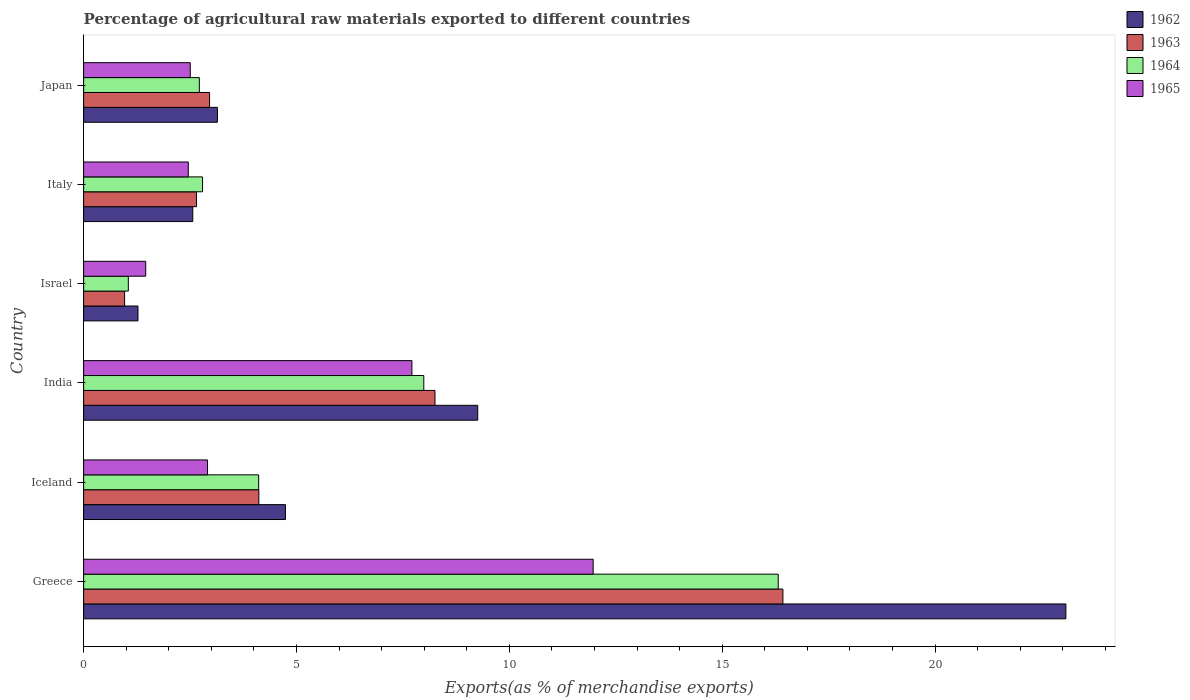How many different coloured bars are there?
Ensure brevity in your answer.  4. How many groups of bars are there?
Your answer should be compact. 6. Are the number of bars per tick equal to the number of legend labels?
Provide a short and direct response. Yes. How many bars are there on the 6th tick from the top?
Your answer should be compact. 4. In how many cases, is the number of bars for a given country not equal to the number of legend labels?
Keep it short and to the point. 0. What is the percentage of exports to different countries in 1962 in Israel?
Keep it short and to the point. 1.28. Across all countries, what is the maximum percentage of exports to different countries in 1963?
Your answer should be compact. 16.43. Across all countries, what is the minimum percentage of exports to different countries in 1963?
Offer a terse response. 0.96. In which country was the percentage of exports to different countries in 1963 maximum?
Provide a short and direct response. Greece. In which country was the percentage of exports to different countries in 1962 minimum?
Make the answer very short. Israel. What is the total percentage of exports to different countries in 1963 in the graph?
Your response must be concise. 35.37. What is the difference between the percentage of exports to different countries in 1963 in Greece and that in India?
Give a very brief answer. 8.17. What is the difference between the percentage of exports to different countries in 1965 in Italy and the percentage of exports to different countries in 1962 in Israel?
Offer a very short reply. 1.18. What is the average percentage of exports to different countries in 1962 per country?
Your answer should be very brief. 7.34. What is the difference between the percentage of exports to different countries in 1963 and percentage of exports to different countries in 1964 in Japan?
Your response must be concise. 0.24. In how many countries, is the percentage of exports to different countries in 1965 greater than 21 %?
Provide a succinct answer. 0. What is the ratio of the percentage of exports to different countries in 1964 in Greece to that in Iceland?
Provide a short and direct response. 3.97. What is the difference between the highest and the second highest percentage of exports to different countries in 1965?
Your answer should be compact. 4.26. What is the difference between the highest and the lowest percentage of exports to different countries in 1965?
Provide a succinct answer. 10.51. In how many countries, is the percentage of exports to different countries in 1964 greater than the average percentage of exports to different countries in 1964 taken over all countries?
Provide a succinct answer. 2. Is it the case that in every country, the sum of the percentage of exports to different countries in 1963 and percentage of exports to different countries in 1964 is greater than the sum of percentage of exports to different countries in 1962 and percentage of exports to different countries in 1965?
Offer a very short reply. No. What does the 2nd bar from the top in Japan represents?
Provide a succinct answer. 1964. What does the 3rd bar from the bottom in Italy represents?
Offer a terse response. 1964. How many bars are there?
Your answer should be compact. 24. What is the difference between two consecutive major ticks on the X-axis?
Keep it short and to the point. 5. Are the values on the major ticks of X-axis written in scientific E-notation?
Your response must be concise. No. How many legend labels are there?
Offer a terse response. 4. What is the title of the graph?
Keep it short and to the point. Percentage of agricultural raw materials exported to different countries. What is the label or title of the X-axis?
Offer a terse response. Exports(as % of merchandise exports). What is the Exports(as % of merchandise exports) of 1962 in Greece?
Ensure brevity in your answer.  23.07. What is the Exports(as % of merchandise exports) of 1963 in Greece?
Make the answer very short. 16.43. What is the Exports(as % of merchandise exports) of 1964 in Greece?
Offer a very short reply. 16.32. What is the Exports(as % of merchandise exports) in 1965 in Greece?
Provide a short and direct response. 11.97. What is the Exports(as % of merchandise exports) in 1962 in Iceland?
Your response must be concise. 4.74. What is the Exports(as % of merchandise exports) in 1963 in Iceland?
Your response must be concise. 4.12. What is the Exports(as % of merchandise exports) of 1964 in Iceland?
Provide a succinct answer. 4.11. What is the Exports(as % of merchandise exports) in 1965 in Iceland?
Provide a succinct answer. 2.91. What is the Exports(as % of merchandise exports) in 1962 in India?
Ensure brevity in your answer.  9.26. What is the Exports(as % of merchandise exports) in 1963 in India?
Make the answer very short. 8.25. What is the Exports(as % of merchandise exports) of 1964 in India?
Provide a short and direct response. 7.99. What is the Exports(as % of merchandise exports) of 1965 in India?
Offer a very short reply. 7.71. What is the Exports(as % of merchandise exports) in 1962 in Israel?
Offer a terse response. 1.28. What is the Exports(as % of merchandise exports) of 1963 in Israel?
Your response must be concise. 0.96. What is the Exports(as % of merchandise exports) in 1964 in Israel?
Give a very brief answer. 1.05. What is the Exports(as % of merchandise exports) in 1965 in Israel?
Ensure brevity in your answer.  1.46. What is the Exports(as % of merchandise exports) of 1962 in Italy?
Give a very brief answer. 2.56. What is the Exports(as % of merchandise exports) in 1963 in Italy?
Provide a short and direct response. 2.65. What is the Exports(as % of merchandise exports) in 1964 in Italy?
Keep it short and to the point. 2.79. What is the Exports(as % of merchandise exports) in 1965 in Italy?
Provide a succinct answer. 2.46. What is the Exports(as % of merchandise exports) in 1962 in Japan?
Provide a succinct answer. 3.14. What is the Exports(as % of merchandise exports) in 1963 in Japan?
Offer a terse response. 2.96. What is the Exports(as % of merchandise exports) of 1964 in Japan?
Provide a short and direct response. 2.72. What is the Exports(as % of merchandise exports) of 1965 in Japan?
Your answer should be compact. 2.5. Across all countries, what is the maximum Exports(as % of merchandise exports) in 1962?
Offer a terse response. 23.07. Across all countries, what is the maximum Exports(as % of merchandise exports) of 1963?
Make the answer very short. 16.43. Across all countries, what is the maximum Exports(as % of merchandise exports) in 1964?
Your answer should be compact. 16.32. Across all countries, what is the maximum Exports(as % of merchandise exports) of 1965?
Offer a terse response. 11.97. Across all countries, what is the minimum Exports(as % of merchandise exports) of 1962?
Ensure brevity in your answer.  1.28. Across all countries, what is the minimum Exports(as % of merchandise exports) of 1963?
Your response must be concise. 0.96. Across all countries, what is the minimum Exports(as % of merchandise exports) in 1964?
Give a very brief answer. 1.05. Across all countries, what is the minimum Exports(as % of merchandise exports) in 1965?
Your response must be concise. 1.46. What is the total Exports(as % of merchandise exports) of 1962 in the graph?
Keep it short and to the point. 44.05. What is the total Exports(as % of merchandise exports) in 1963 in the graph?
Make the answer very short. 35.37. What is the total Exports(as % of merchandise exports) in 1964 in the graph?
Make the answer very short. 34.98. What is the total Exports(as % of merchandise exports) in 1965 in the graph?
Your response must be concise. 29.01. What is the difference between the Exports(as % of merchandise exports) of 1962 in Greece and that in Iceland?
Ensure brevity in your answer.  18.33. What is the difference between the Exports(as % of merchandise exports) of 1963 in Greece and that in Iceland?
Keep it short and to the point. 12.31. What is the difference between the Exports(as % of merchandise exports) in 1964 in Greece and that in Iceland?
Provide a short and direct response. 12.2. What is the difference between the Exports(as % of merchandise exports) in 1965 in Greece and that in Iceland?
Make the answer very short. 9.06. What is the difference between the Exports(as % of merchandise exports) in 1962 in Greece and that in India?
Provide a short and direct response. 13.81. What is the difference between the Exports(as % of merchandise exports) of 1963 in Greece and that in India?
Make the answer very short. 8.17. What is the difference between the Exports(as % of merchandise exports) in 1964 in Greece and that in India?
Provide a succinct answer. 8.33. What is the difference between the Exports(as % of merchandise exports) in 1965 in Greece and that in India?
Provide a short and direct response. 4.26. What is the difference between the Exports(as % of merchandise exports) in 1962 in Greece and that in Israel?
Keep it short and to the point. 21.8. What is the difference between the Exports(as % of merchandise exports) in 1963 in Greece and that in Israel?
Keep it short and to the point. 15.46. What is the difference between the Exports(as % of merchandise exports) in 1964 in Greece and that in Israel?
Provide a succinct answer. 15.27. What is the difference between the Exports(as % of merchandise exports) in 1965 in Greece and that in Israel?
Your answer should be compact. 10.51. What is the difference between the Exports(as % of merchandise exports) in 1962 in Greece and that in Italy?
Make the answer very short. 20.51. What is the difference between the Exports(as % of merchandise exports) in 1963 in Greece and that in Italy?
Make the answer very short. 13.77. What is the difference between the Exports(as % of merchandise exports) in 1964 in Greece and that in Italy?
Keep it short and to the point. 13.52. What is the difference between the Exports(as % of merchandise exports) in 1965 in Greece and that in Italy?
Offer a very short reply. 9.51. What is the difference between the Exports(as % of merchandise exports) in 1962 in Greece and that in Japan?
Your response must be concise. 19.93. What is the difference between the Exports(as % of merchandise exports) in 1963 in Greece and that in Japan?
Give a very brief answer. 13.47. What is the difference between the Exports(as % of merchandise exports) in 1964 in Greece and that in Japan?
Keep it short and to the point. 13.6. What is the difference between the Exports(as % of merchandise exports) of 1965 in Greece and that in Japan?
Offer a terse response. 9.46. What is the difference between the Exports(as % of merchandise exports) of 1962 in Iceland and that in India?
Your response must be concise. -4.52. What is the difference between the Exports(as % of merchandise exports) in 1963 in Iceland and that in India?
Provide a short and direct response. -4.14. What is the difference between the Exports(as % of merchandise exports) in 1964 in Iceland and that in India?
Keep it short and to the point. -3.88. What is the difference between the Exports(as % of merchandise exports) in 1965 in Iceland and that in India?
Your answer should be very brief. -4.8. What is the difference between the Exports(as % of merchandise exports) of 1962 in Iceland and that in Israel?
Make the answer very short. 3.46. What is the difference between the Exports(as % of merchandise exports) of 1963 in Iceland and that in Israel?
Your response must be concise. 3.15. What is the difference between the Exports(as % of merchandise exports) of 1964 in Iceland and that in Israel?
Provide a succinct answer. 3.06. What is the difference between the Exports(as % of merchandise exports) of 1965 in Iceland and that in Israel?
Keep it short and to the point. 1.45. What is the difference between the Exports(as % of merchandise exports) of 1962 in Iceland and that in Italy?
Offer a very short reply. 2.18. What is the difference between the Exports(as % of merchandise exports) of 1963 in Iceland and that in Italy?
Provide a succinct answer. 1.46. What is the difference between the Exports(as % of merchandise exports) in 1964 in Iceland and that in Italy?
Keep it short and to the point. 1.32. What is the difference between the Exports(as % of merchandise exports) of 1965 in Iceland and that in Italy?
Your response must be concise. 0.45. What is the difference between the Exports(as % of merchandise exports) in 1962 in Iceland and that in Japan?
Make the answer very short. 1.6. What is the difference between the Exports(as % of merchandise exports) of 1963 in Iceland and that in Japan?
Ensure brevity in your answer.  1.16. What is the difference between the Exports(as % of merchandise exports) of 1964 in Iceland and that in Japan?
Offer a very short reply. 1.39. What is the difference between the Exports(as % of merchandise exports) of 1965 in Iceland and that in Japan?
Your response must be concise. 0.41. What is the difference between the Exports(as % of merchandise exports) of 1962 in India and that in Israel?
Ensure brevity in your answer.  7.98. What is the difference between the Exports(as % of merchandise exports) in 1963 in India and that in Israel?
Keep it short and to the point. 7.29. What is the difference between the Exports(as % of merchandise exports) of 1964 in India and that in Israel?
Provide a short and direct response. 6.94. What is the difference between the Exports(as % of merchandise exports) in 1965 in India and that in Israel?
Offer a terse response. 6.25. What is the difference between the Exports(as % of merchandise exports) in 1962 in India and that in Italy?
Provide a succinct answer. 6.69. What is the difference between the Exports(as % of merchandise exports) in 1963 in India and that in Italy?
Provide a short and direct response. 5.6. What is the difference between the Exports(as % of merchandise exports) of 1964 in India and that in Italy?
Offer a terse response. 5.2. What is the difference between the Exports(as % of merchandise exports) in 1965 in India and that in Italy?
Provide a succinct answer. 5.25. What is the difference between the Exports(as % of merchandise exports) of 1962 in India and that in Japan?
Provide a succinct answer. 6.11. What is the difference between the Exports(as % of merchandise exports) of 1963 in India and that in Japan?
Ensure brevity in your answer.  5.29. What is the difference between the Exports(as % of merchandise exports) in 1964 in India and that in Japan?
Offer a terse response. 5.27. What is the difference between the Exports(as % of merchandise exports) of 1965 in India and that in Japan?
Provide a short and direct response. 5.21. What is the difference between the Exports(as % of merchandise exports) in 1962 in Israel and that in Italy?
Offer a terse response. -1.29. What is the difference between the Exports(as % of merchandise exports) in 1963 in Israel and that in Italy?
Your response must be concise. -1.69. What is the difference between the Exports(as % of merchandise exports) of 1964 in Israel and that in Italy?
Offer a very short reply. -1.74. What is the difference between the Exports(as % of merchandise exports) of 1965 in Israel and that in Italy?
Provide a succinct answer. -1. What is the difference between the Exports(as % of merchandise exports) in 1962 in Israel and that in Japan?
Make the answer very short. -1.87. What is the difference between the Exports(as % of merchandise exports) of 1963 in Israel and that in Japan?
Your response must be concise. -2. What is the difference between the Exports(as % of merchandise exports) in 1964 in Israel and that in Japan?
Provide a short and direct response. -1.67. What is the difference between the Exports(as % of merchandise exports) in 1965 in Israel and that in Japan?
Provide a succinct answer. -1.05. What is the difference between the Exports(as % of merchandise exports) of 1962 in Italy and that in Japan?
Ensure brevity in your answer.  -0.58. What is the difference between the Exports(as % of merchandise exports) of 1963 in Italy and that in Japan?
Your response must be concise. -0.31. What is the difference between the Exports(as % of merchandise exports) of 1964 in Italy and that in Japan?
Ensure brevity in your answer.  0.07. What is the difference between the Exports(as % of merchandise exports) of 1965 in Italy and that in Japan?
Your response must be concise. -0.05. What is the difference between the Exports(as % of merchandise exports) in 1962 in Greece and the Exports(as % of merchandise exports) in 1963 in Iceland?
Ensure brevity in your answer.  18.96. What is the difference between the Exports(as % of merchandise exports) in 1962 in Greece and the Exports(as % of merchandise exports) in 1964 in Iceland?
Provide a succinct answer. 18.96. What is the difference between the Exports(as % of merchandise exports) in 1962 in Greece and the Exports(as % of merchandise exports) in 1965 in Iceland?
Give a very brief answer. 20.16. What is the difference between the Exports(as % of merchandise exports) of 1963 in Greece and the Exports(as % of merchandise exports) of 1964 in Iceland?
Keep it short and to the point. 12.31. What is the difference between the Exports(as % of merchandise exports) in 1963 in Greece and the Exports(as % of merchandise exports) in 1965 in Iceland?
Ensure brevity in your answer.  13.52. What is the difference between the Exports(as % of merchandise exports) in 1964 in Greece and the Exports(as % of merchandise exports) in 1965 in Iceland?
Keep it short and to the point. 13.41. What is the difference between the Exports(as % of merchandise exports) of 1962 in Greece and the Exports(as % of merchandise exports) of 1963 in India?
Ensure brevity in your answer.  14.82. What is the difference between the Exports(as % of merchandise exports) in 1962 in Greece and the Exports(as % of merchandise exports) in 1964 in India?
Your answer should be compact. 15.08. What is the difference between the Exports(as % of merchandise exports) in 1962 in Greece and the Exports(as % of merchandise exports) in 1965 in India?
Offer a very short reply. 15.36. What is the difference between the Exports(as % of merchandise exports) of 1963 in Greece and the Exports(as % of merchandise exports) of 1964 in India?
Provide a short and direct response. 8.44. What is the difference between the Exports(as % of merchandise exports) in 1963 in Greece and the Exports(as % of merchandise exports) in 1965 in India?
Offer a terse response. 8.71. What is the difference between the Exports(as % of merchandise exports) in 1964 in Greece and the Exports(as % of merchandise exports) in 1965 in India?
Your answer should be compact. 8.6. What is the difference between the Exports(as % of merchandise exports) in 1962 in Greece and the Exports(as % of merchandise exports) in 1963 in Israel?
Offer a terse response. 22.11. What is the difference between the Exports(as % of merchandise exports) of 1962 in Greece and the Exports(as % of merchandise exports) of 1964 in Israel?
Your answer should be compact. 22.02. What is the difference between the Exports(as % of merchandise exports) of 1962 in Greece and the Exports(as % of merchandise exports) of 1965 in Israel?
Make the answer very short. 21.61. What is the difference between the Exports(as % of merchandise exports) in 1963 in Greece and the Exports(as % of merchandise exports) in 1964 in Israel?
Ensure brevity in your answer.  15.38. What is the difference between the Exports(as % of merchandise exports) of 1963 in Greece and the Exports(as % of merchandise exports) of 1965 in Israel?
Give a very brief answer. 14.97. What is the difference between the Exports(as % of merchandise exports) of 1964 in Greece and the Exports(as % of merchandise exports) of 1965 in Israel?
Ensure brevity in your answer.  14.86. What is the difference between the Exports(as % of merchandise exports) in 1962 in Greece and the Exports(as % of merchandise exports) in 1963 in Italy?
Your answer should be compact. 20.42. What is the difference between the Exports(as % of merchandise exports) in 1962 in Greece and the Exports(as % of merchandise exports) in 1964 in Italy?
Keep it short and to the point. 20.28. What is the difference between the Exports(as % of merchandise exports) of 1962 in Greece and the Exports(as % of merchandise exports) of 1965 in Italy?
Give a very brief answer. 20.61. What is the difference between the Exports(as % of merchandise exports) of 1963 in Greece and the Exports(as % of merchandise exports) of 1964 in Italy?
Your response must be concise. 13.63. What is the difference between the Exports(as % of merchandise exports) in 1963 in Greece and the Exports(as % of merchandise exports) in 1965 in Italy?
Ensure brevity in your answer.  13.97. What is the difference between the Exports(as % of merchandise exports) of 1964 in Greece and the Exports(as % of merchandise exports) of 1965 in Italy?
Your response must be concise. 13.86. What is the difference between the Exports(as % of merchandise exports) in 1962 in Greece and the Exports(as % of merchandise exports) in 1963 in Japan?
Your answer should be very brief. 20.11. What is the difference between the Exports(as % of merchandise exports) of 1962 in Greece and the Exports(as % of merchandise exports) of 1964 in Japan?
Your response must be concise. 20.35. What is the difference between the Exports(as % of merchandise exports) of 1962 in Greece and the Exports(as % of merchandise exports) of 1965 in Japan?
Your answer should be very brief. 20.57. What is the difference between the Exports(as % of merchandise exports) of 1963 in Greece and the Exports(as % of merchandise exports) of 1964 in Japan?
Offer a very short reply. 13.71. What is the difference between the Exports(as % of merchandise exports) of 1963 in Greece and the Exports(as % of merchandise exports) of 1965 in Japan?
Ensure brevity in your answer.  13.92. What is the difference between the Exports(as % of merchandise exports) of 1964 in Greece and the Exports(as % of merchandise exports) of 1965 in Japan?
Make the answer very short. 13.81. What is the difference between the Exports(as % of merchandise exports) in 1962 in Iceland and the Exports(as % of merchandise exports) in 1963 in India?
Provide a succinct answer. -3.51. What is the difference between the Exports(as % of merchandise exports) of 1962 in Iceland and the Exports(as % of merchandise exports) of 1964 in India?
Offer a terse response. -3.25. What is the difference between the Exports(as % of merchandise exports) of 1962 in Iceland and the Exports(as % of merchandise exports) of 1965 in India?
Offer a terse response. -2.97. What is the difference between the Exports(as % of merchandise exports) in 1963 in Iceland and the Exports(as % of merchandise exports) in 1964 in India?
Provide a succinct answer. -3.87. What is the difference between the Exports(as % of merchandise exports) in 1963 in Iceland and the Exports(as % of merchandise exports) in 1965 in India?
Ensure brevity in your answer.  -3.6. What is the difference between the Exports(as % of merchandise exports) in 1964 in Iceland and the Exports(as % of merchandise exports) in 1965 in India?
Ensure brevity in your answer.  -3.6. What is the difference between the Exports(as % of merchandise exports) of 1962 in Iceland and the Exports(as % of merchandise exports) of 1963 in Israel?
Offer a very short reply. 3.78. What is the difference between the Exports(as % of merchandise exports) in 1962 in Iceland and the Exports(as % of merchandise exports) in 1964 in Israel?
Your answer should be very brief. 3.69. What is the difference between the Exports(as % of merchandise exports) in 1962 in Iceland and the Exports(as % of merchandise exports) in 1965 in Israel?
Provide a succinct answer. 3.28. What is the difference between the Exports(as % of merchandise exports) in 1963 in Iceland and the Exports(as % of merchandise exports) in 1964 in Israel?
Your answer should be compact. 3.07. What is the difference between the Exports(as % of merchandise exports) of 1963 in Iceland and the Exports(as % of merchandise exports) of 1965 in Israel?
Make the answer very short. 2.66. What is the difference between the Exports(as % of merchandise exports) in 1964 in Iceland and the Exports(as % of merchandise exports) in 1965 in Israel?
Your answer should be very brief. 2.65. What is the difference between the Exports(as % of merchandise exports) in 1962 in Iceland and the Exports(as % of merchandise exports) in 1963 in Italy?
Provide a short and direct response. 2.09. What is the difference between the Exports(as % of merchandise exports) in 1962 in Iceland and the Exports(as % of merchandise exports) in 1964 in Italy?
Ensure brevity in your answer.  1.95. What is the difference between the Exports(as % of merchandise exports) of 1962 in Iceland and the Exports(as % of merchandise exports) of 1965 in Italy?
Your response must be concise. 2.28. What is the difference between the Exports(as % of merchandise exports) in 1963 in Iceland and the Exports(as % of merchandise exports) in 1964 in Italy?
Your answer should be compact. 1.32. What is the difference between the Exports(as % of merchandise exports) in 1963 in Iceland and the Exports(as % of merchandise exports) in 1965 in Italy?
Your answer should be very brief. 1.66. What is the difference between the Exports(as % of merchandise exports) of 1964 in Iceland and the Exports(as % of merchandise exports) of 1965 in Italy?
Make the answer very short. 1.65. What is the difference between the Exports(as % of merchandise exports) of 1962 in Iceland and the Exports(as % of merchandise exports) of 1963 in Japan?
Your answer should be very brief. 1.78. What is the difference between the Exports(as % of merchandise exports) of 1962 in Iceland and the Exports(as % of merchandise exports) of 1964 in Japan?
Offer a terse response. 2.02. What is the difference between the Exports(as % of merchandise exports) in 1962 in Iceland and the Exports(as % of merchandise exports) in 1965 in Japan?
Keep it short and to the point. 2.24. What is the difference between the Exports(as % of merchandise exports) of 1963 in Iceland and the Exports(as % of merchandise exports) of 1964 in Japan?
Your answer should be very brief. 1.4. What is the difference between the Exports(as % of merchandise exports) in 1963 in Iceland and the Exports(as % of merchandise exports) in 1965 in Japan?
Your response must be concise. 1.61. What is the difference between the Exports(as % of merchandise exports) of 1964 in Iceland and the Exports(as % of merchandise exports) of 1965 in Japan?
Provide a short and direct response. 1.61. What is the difference between the Exports(as % of merchandise exports) in 1962 in India and the Exports(as % of merchandise exports) in 1963 in Israel?
Keep it short and to the point. 8.3. What is the difference between the Exports(as % of merchandise exports) in 1962 in India and the Exports(as % of merchandise exports) in 1964 in Israel?
Your answer should be very brief. 8.21. What is the difference between the Exports(as % of merchandise exports) in 1962 in India and the Exports(as % of merchandise exports) in 1965 in Israel?
Make the answer very short. 7.8. What is the difference between the Exports(as % of merchandise exports) of 1963 in India and the Exports(as % of merchandise exports) of 1964 in Israel?
Offer a terse response. 7.2. What is the difference between the Exports(as % of merchandise exports) of 1963 in India and the Exports(as % of merchandise exports) of 1965 in Israel?
Make the answer very short. 6.79. What is the difference between the Exports(as % of merchandise exports) of 1964 in India and the Exports(as % of merchandise exports) of 1965 in Israel?
Give a very brief answer. 6.53. What is the difference between the Exports(as % of merchandise exports) of 1962 in India and the Exports(as % of merchandise exports) of 1963 in Italy?
Provide a succinct answer. 6.61. What is the difference between the Exports(as % of merchandise exports) of 1962 in India and the Exports(as % of merchandise exports) of 1964 in Italy?
Your answer should be compact. 6.46. What is the difference between the Exports(as % of merchandise exports) of 1962 in India and the Exports(as % of merchandise exports) of 1965 in Italy?
Offer a terse response. 6.8. What is the difference between the Exports(as % of merchandise exports) in 1963 in India and the Exports(as % of merchandise exports) in 1964 in Italy?
Your answer should be compact. 5.46. What is the difference between the Exports(as % of merchandise exports) of 1963 in India and the Exports(as % of merchandise exports) of 1965 in Italy?
Give a very brief answer. 5.79. What is the difference between the Exports(as % of merchandise exports) of 1964 in India and the Exports(as % of merchandise exports) of 1965 in Italy?
Provide a succinct answer. 5.53. What is the difference between the Exports(as % of merchandise exports) in 1962 in India and the Exports(as % of merchandise exports) in 1963 in Japan?
Give a very brief answer. 6.3. What is the difference between the Exports(as % of merchandise exports) in 1962 in India and the Exports(as % of merchandise exports) in 1964 in Japan?
Provide a succinct answer. 6.54. What is the difference between the Exports(as % of merchandise exports) of 1962 in India and the Exports(as % of merchandise exports) of 1965 in Japan?
Keep it short and to the point. 6.75. What is the difference between the Exports(as % of merchandise exports) in 1963 in India and the Exports(as % of merchandise exports) in 1964 in Japan?
Give a very brief answer. 5.54. What is the difference between the Exports(as % of merchandise exports) in 1963 in India and the Exports(as % of merchandise exports) in 1965 in Japan?
Offer a very short reply. 5.75. What is the difference between the Exports(as % of merchandise exports) of 1964 in India and the Exports(as % of merchandise exports) of 1965 in Japan?
Offer a very short reply. 5.49. What is the difference between the Exports(as % of merchandise exports) of 1962 in Israel and the Exports(as % of merchandise exports) of 1963 in Italy?
Offer a terse response. -1.38. What is the difference between the Exports(as % of merchandise exports) in 1962 in Israel and the Exports(as % of merchandise exports) in 1964 in Italy?
Provide a succinct answer. -1.52. What is the difference between the Exports(as % of merchandise exports) of 1962 in Israel and the Exports(as % of merchandise exports) of 1965 in Italy?
Offer a very short reply. -1.18. What is the difference between the Exports(as % of merchandise exports) in 1963 in Israel and the Exports(as % of merchandise exports) in 1964 in Italy?
Make the answer very short. -1.83. What is the difference between the Exports(as % of merchandise exports) in 1963 in Israel and the Exports(as % of merchandise exports) in 1965 in Italy?
Make the answer very short. -1.5. What is the difference between the Exports(as % of merchandise exports) of 1964 in Israel and the Exports(as % of merchandise exports) of 1965 in Italy?
Offer a terse response. -1.41. What is the difference between the Exports(as % of merchandise exports) of 1962 in Israel and the Exports(as % of merchandise exports) of 1963 in Japan?
Your answer should be compact. -1.68. What is the difference between the Exports(as % of merchandise exports) of 1962 in Israel and the Exports(as % of merchandise exports) of 1964 in Japan?
Ensure brevity in your answer.  -1.44. What is the difference between the Exports(as % of merchandise exports) of 1962 in Israel and the Exports(as % of merchandise exports) of 1965 in Japan?
Provide a short and direct response. -1.23. What is the difference between the Exports(as % of merchandise exports) of 1963 in Israel and the Exports(as % of merchandise exports) of 1964 in Japan?
Provide a short and direct response. -1.76. What is the difference between the Exports(as % of merchandise exports) in 1963 in Israel and the Exports(as % of merchandise exports) in 1965 in Japan?
Offer a very short reply. -1.54. What is the difference between the Exports(as % of merchandise exports) of 1964 in Israel and the Exports(as % of merchandise exports) of 1965 in Japan?
Keep it short and to the point. -1.45. What is the difference between the Exports(as % of merchandise exports) of 1962 in Italy and the Exports(as % of merchandise exports) of 1963 in Japan?
Your answer should be compact. -0.39. What is the difference between the Exports(as % of merchandise exports) in 1962 in Italy and the Exports(as % of merchandise exports) in 1964 in Japan?
Keep it short and to the point. -0.15. What is the difference between the Exports(as % of merchandise exports) of 1962 in Italy and the Exports(as % of merchandise exports) of 1965 in Japan?
Provide a succinct answer. 0.06. What is the difference between the Exports(as % of merchandise exports) in 1963 in Italy and the Exports(as % of merchandise exports) in 1964 in Japan?
Your response must be concise. -0.07. What is the difference between the Exports(as % of merchandise exports) in 1963 in Italy and the Exports(as % of merchandise exports) in 1965 in Japan?
Your answer should be compact. 0.15. What is the difference between the Exports(as % of merchandise exports) of 1964 in Italy and the Exports(as % of merchandise exports) of 1965 in Japan?
Make the answer very short. 0.29. What is the average Exports(as % of merchandise exports) in 1962 per country?
Make the answer very short. 7.34. What is the average Exports(as % of merchandise exports) in 1963 per country?
Give a very brief answer. 5.89. What is the average Exports(as % of merchandise exports) of 1964 per country?
Provide a short and direct response. 5.83. What is the average Exports(as % of merchandise exports) in 1965 per country?
Give a very brief answer. 4.84. What is the difference between the Exports(as % of merchandise exports) in 1962 and Exports(as % of merchandise exports) in 1963 in Greece?
Your answer should be compact. 6.65. What is the difference between the Exports(as % of merchandise exports) of 1962 and Exports(as % of merchandise exports) of 1964 in Greece?
Your answer should be very brief. 6.76. What is the difference between the Exports(as % of merchandise exports) of 1962 and Exports(as % of merchandise exports) of 1965 in Greece?
Your response must be concise. 11.1. What is the difference between the Exports(as % of merchandise exports) of 1963 and Exports(as % of merchandise exports) of 1964 in Greece?
Give a very brief answer. 0.11. What is the difference between the Exports(as % of merchandise exports) in 1963 and Exports(as % of merchandise exports) in 1965 in Greece?
Make the answer very short. 4.46. What is the difference between the Exports(as % of merchandise exports) of 1964 and Exports(as % of merchandise exports) of 1965 in Greece?
Provide a short and direct response. 4.35. What is the difference between the Exports(as % of merchandise exports) in 1962 and Exports(as % of merchandise exports) in 1963 in Iceland?
Offer a terse response. 0.63. What is the difference between the Exports(as % of merchandise exports) of 1962 and Exports(as % of merchandise exports) of 1964 in Iceland?
Offer a very short reply. 0.63. What is the difference between the Exports(as % of merchandise exports) in 1962 and Exports(as % of merchandise exports) in 1965 in Iceland?
Provide a short and direct response. 1.83. What is the difference between the Exports(as % of merchandise exports) in 1963 and Exports(as % of merchandise exports) in 1964 in Iceland?
Your response must be concise. 0. What is the difference between the Exports(as % of merchandise exports) of 1963 and Exports(as % of merchandise exports) of 1965 in Iceland?
Provide a short and direct response. 1.21. What is the difference between the Exports(as % of merchandise exports) in 1964 and Exports(as % of merchandise exports) in 1965 in Iceland?
Your response must be concise. 1.2. What is the difference between the Exports(as % of merchandise exports) of 1962 and Exports(as % of merchandise exports) of 1963 in India?
Keep it short and to the point. 1. What is the difference between the Exports(as % of merchandise exports) of 1962 and Exports(as % of merchandise exports) of 1964 in India?
Your answer should be compact. 1.27. What is the difference between the Exports(as % of merchandise exports) in 1962 and Exports(as % of merchandise exports) in 1965 in India?
Keep it short and to the point. 1.55. What is the difference between the Exports(as % of merchandise exports) in 1963 and Exports(as % of merchandise exports) in 1964 in India?
Provide a short and direct response. 0.26. What is the difference between the Exports(as % of merchandise exports) of 1963 and Exports(as % of merchandise exports) of 1965 in India?
Give a very brief answer. 0.54. What is the difference between the Exports(as % of merchandise exports) of 1964 and Exports(as % of merchandise exports) of 1965 in India?
Provide a succinct answer. 0.28. What is the difference between the Exports(as % of merchandise exports) of 1962 and Exports(as % of merchandise exports) of 1963 in Israel?
Ensure brevity in your answer.  0.31. What is the difference between the Exports(as % of merchandise exports) in 1962 and Exports(as % of merchandise exports) in 1964 in Israel?
Your response must be concise. 0.23. What is the difference between the Exports(as % of merchandise exports) of 1962 and Exports(as % of merchandise exports) of 1965 in Israel?
Your answer should be very brief. -0.18. What is the difference between the Exports(as % of merchandise exports) in 1963 and Exports(as % of merchandise exports) in 1964 in Israel?
Your response must be concise. -0.09. What is the difference between the Exports(as % of merchandise exports) in 1963 and Exports(as % of merchandise exports) in 1965 in Israel?
Ensure brevity in your answer.  -0.5. What is the difference between the Exports(as % of merchandise exports) of 1964 and Exports(as % of merchandise exports) of 1965 in Israel?
Your answer should be compact. -0.41. What is the difference between the Exports(as % of merchandise exports) in 1962 and Exports(as % of merchandise exports) in 1963 in Italy?
Your answer should be very brief. -0.09. What is the difference between the Exports(as % of merchandise exports) in 1962 and Exports(as % of merchandise exports) in 1964 in Italy?
Your answer should be very brief. -0.23. What is the difference between the Exports(as % of merchandise exports) in 1962 and Exports(as % of merchandise exports) in 1965 in Italy?
Your answer should be compact. 0.1. What is the difference between the Exports(as % of merchandise exports) in 1963 and Exports(as % of merchandise exports) in 1964 in Italy?
Give a very brief answer. -0.14. What is the difference between the Exports(as % of merchandise exports) of 1963 and Exports(as % of merchandise exports) of 1965 in Italy?
Offer a very short reply. 0.19. What is the difference between the Exports(as % of merchandise exports) in 1964 and Exports(as % of merchandise exports) in 1965 in Italy?
Keep it short and to the point. 0.33. What is the difference between the Exports(as % of merchandise exports) of 1962 and Exports(as % of merchandise exports) of 1963 in Japan?
Your answer should be compact. 0.18. What is the difference between the Exports(as % of merchandise exports) of 1962 and Exports(as % of merchandise exports) of 1964 in Japan?
Your answer should be compact. 0.42. What is the difference between the Exports(as % of merchandise exports) in 1962 and Exports(as % of merchandise exports) in 1965 in Japan?
Keep it short and to the point. 0.64. What is the difference between the Exports(as % of merchandise exports) in 1963 and Exports(as % of merchandise exports) in 1964 in Japan?
Provide a succinct answer. 0.24. What is the difference between the Exports(as % of merchandise exports) in 1963 and Exports(as % of merchandise exports) in 1965 in Japan?
Your answer should be compact. 0.45. What is the difference between the Exports(as % of merchandise exports) in 1964 and Exports(as % of merchandise exports) in 1965 in Japan?
Offer a very short reply. 0.21. What is the ratio of the Exports(as % of merchandise exports) in 1962 in Greece to that in Iceland?
Your response must be concise. 4.87. What is the ratio of the Exports(as % of merchandise exports) in 1963 in Greece to that in Iceland?
Give a very brief answer. 3.99. What is the ratio of the Exports(as % of merchandise exports) in 1964 in Greece to that in Iceland?
Offer a terse response. 3.97. What is the ratio of the Exports(as % of merchandise exports) of 1965 in Greece to that in Iceland?
Keep it short and to the point. 4.11. What is the ratio of the Exports(as % of merchandise exports) of 1962 in Greece to that in India?
Your answer should be very brief. 2.49. What is the ratio of the Exports(as % of merchandise exports) in 1963 in Greece to that in India?
Your answer should be compact. 1.99. What is the ratio of the Exports(as % of merchandise exports) of 1964 in Greece to that in India?
Your answer should be very brief. 2.04. What is the ratio of the Exports(as % of merchandise exports) of 1965 in Greece to that in India?
Provide a succinct answer. 1.55. What is the ratio of the Exports(as % of merchandise exports) in 1962 in Greece to that in Israel?
Keep it short and to the point. 18.07. What is the ratio of the Exports(as % of merchandise exports) in 1963 in Greece to that in Israel?
Ensure brevity in your answer.  17.07. What is the ratio of the Exports(as % of merchandise exports) of 1964 in Greece to that in Israel?
Give a very brief answer. 15.54. What is the ratio of the Exports(as % of merchandise exports) of 1965 in Greece to that in Israel?
Offer a very short reply. 8.21. What is the ratio of the Exports(as % of merchandise exports) of 1962 in Greece to that in Italy?
Provide a short and direct response. 9. What is the ratio of the Exports(as % of merchandise exports) of 1963 in Greece to that in Italy?
Provide a succinct answer. 6.19. What is the ratio of the Exports(as % of merchandise exports) in 1964 in Greece to that in Italy?
Your answer should be very brief. 5.84. What is the ratio of the Exports(as % of merchandise exports) in 1965 in Greece to that in Italy?
Provide a succinct answer. 4.87. What is the ratio of the Exports(as % of merchandise exports) of 1962 in Greece to that in Japan?
Provide a succinct answer. 7.34. What is the ratio of the Exports(as % of merchandise exports) in 1963 in Greece to that in Japan?
Give a very brief answer. 5.55. What is the ratio of the Exports(as % of merchandise exports) of 1964 in Greece to that in Japan?
Make the answer very short. 6. What is the ratio of the Exports(as % of merchandise exports) in 1965 in Greece to that in Japan?
Offer a very short reply. 4.78. What is the ratio of the Exports(as % of merchandise exports) in 1962 in Iceland to that in India?
Keep it short and to the point. 0.51. What is the ratio of the Exports(as % of merchandise exports) in 1963 in Iceland to that in India?
Provide a short and direct response. 0.5. What is the ratio of the Exports(as % of merchandise exports) of 1964 in Iceland to that in India?
Ensure brevity in your answer.  0.51. What is the ratio of the Exports(as % of merchandise exports) of 1965 in Iceland to that in India?
Ensure brevity in your answer.  0.38. What is the ratio of the Exports(as % of merchandise exports) in 1962 in Iceland to that in Israel?
Offer a very short reply. 3.71. What is the ratio of the Exports(as % of merchandise exports) of 1963 in Iceland to that in Israel?
Your answer should be very brief. 4.28. What is the ratio of the Exports(as % of merchandise exports) in 1964 in Iceland to that in Israel?
Provide a succinct answer. 3.92. What is the ratio of the Exports(as % of merchandise exports) of 1965 in Iceland to that in Israel?
Give a very brief answer. 2. What is the ratio of the Exports(as % of merchandise exports) in 1962 in Iceland to that in Italy?
Offer a very short reply. 1.85. What is the ratio of the Exports(as % of merchandise exports) of 1963 in Iceland to that in Italy?
Give a very brief answer. 1.55. What is the ratio of the Exports(as % of merchandise exports) of 1964 in Iceland to that in Italy?
Your response must be concise. 1.47. What is the ratio of the Exports(as % of merchandise exports) of 1965 in Iceland to that in Italy?
Ensure brevity in your answer.  1.18. What is the ratio of the Exports(as % of merchandise exports) of 1962 in Iceland to that in Japan?
Offer a terse response. 1.51. What is the ratio of the Exports(as % of merchandise exports) of 1963 in Iceland to that in Japan?
Offer a very short reply. 1.39. What is the ratio of the Exports(as % of merchandise exports) in 1964 in Iceland to that in Japan?
Your answer should be compact. 1.51. What is the ratio of the Exports(as % of merchandise exports) of 1965 in Iceland to that in Japan?
Offer a terse response. 1.16. What is the ratio of the Exports(as % of merchandise exports) of 1962 in India to that in Israel?
Provide a short and direct response. 7.25. What is the ratio of the Exports(as % of merchandise exports) of 1963 in India to that in Israel?
Offer a very short reply. 8.58. What is the ratio of the Exports(as % of merchandise exports) in 1964 in India to that in Israel?
Your answer should be compact. 7.61. What is the ratio of the Exports(as % of merchandise exports) of 1965 in India to that in Israel?
Offer a very short reply. 5.29. What is the ratio of the Exports(as % of merchandise exports) of 1962 in India to that in Italy?
Provide a succinct answer. 3.61. What is the ratio of the Exports(as % of merchandise exports) of 1963 in India to that in Italy?
Your response must be concise. 3.11. What is the ratio of the Exports(as % of merchandise exports) in 1964 in India to that in Italy?
Your answer should be compact. 2.86. What is the ratio of the Exports(as % of merchandise exports) of 1965 in India to that in Italy?
Make the answer very short. 3.14. What is the ratio of the Exports(as % of merchandise exports) of 1962 in India to that in Japan?
Offer a very short reply. 2.95. What is the ratio of the Exports(as % of merchandise exports) in 1963 in India to that in Japan?
Keep it short and to the point. 2.79. What is the ratio of the Exports(as % of merchandise exports) in 1964 in India to that in Japan?
Provide a succinct answer. 2.94. What is the ratio of the Exports(as % of merchandise exports) in 1965 in India to that in Japan?
Ensure brevity in your answer.  3.08. What is the ratio of the Exports(as % of merchandise exports) of 1962 in Israel to that in Italy?
Your answer should be compact. 0.5. What is the ratio of the Exports(as % of merchandise exports) in 1963 in Israel to that in Italy?
Your response must be concise. 0.36. What is the ratio of the Exports(as % of merchandise exports) of 1964 in Israel to that in Italy?
Your answer should be compact. 0.38. What is the ratio of the Exports(as % of merchandise exports) of 1965 in Israel to that in Italy?
Provide a short and direct response. 0.59. What is the ratio of the Exports(as % of merchandise exports) of 1962 in Israel to that in Japan?
Ensure brevity in your answer.  0.41. What is the ratio of the Exports(as % of merchandise exports) in 1963 in Israel to that in Japan?
Offer a very short reply. 0.33. What is the ratio of the Exports(as % of merchandise exports) in 1964 in Israel to that in Japan?
Your answer should be compact. 0.39. What is the ratio of the Exports(as % of merchandise exports) of 1965 in Israel to that in Japan?
Offer a very short reply. 0.58. What is the ratio of the Exports(as % of merchandise exports) of 1962 in Italy to that in Japan?
Ensure brevity in your answer.  0.82. What is the ratio of the Exports(as % of merchandise exports) of 1963 in Italy to that in Japan?
Make the answer very short. 0.9. What is the ratio of the Exports(as % of merchandise exports) of 1964 in Italy to that in Japan?
Ensure brevity in your answer.  1.03. What is the ratio of the Exports(as % of merchandise exports) in 1965 in Italy to that in Japan?
Provide a succinct answer. 0.98. What is the difference between the highest and the second highest Exports(as % of merchandise exports) in 1962?
Your answer should be very brief. 13.81. What is the difference between the highest and the second highest Exports(as % of merchandise exports) of 1963?
Ensure brevity in your answer.  8.17. What is the difference between the highest and the second highest Exports(as % of merchandise exports) of 1964?
Offer a terse response. 8.33. What is the difference between the highest and the second highest Exports(as % of merchandise exports) of 1965?
Provide a short and direct response. 4.26. What is the difference between the highest and the lowest Exports(as % of merchandise exports) in 1962?
Ensure brevity in your answer.  21.8. What is the difference between the highest and the lowest Exports(as % of merchandise exports) of 1963?
Your answer should be compact. 15.46. What is the difference between the highest and the lowest Exports(as % of merchandise exports) in 1964?
Provide a succinct answer. 15.27. What is the difference between the highest and the lowest Exports(as % of merchandise exports) of 1965?
Your response must be concise. 10.51. 